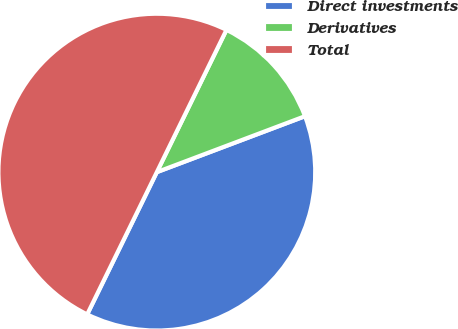Convert chart. <chart><loc_0><loc_0><loc_500><loc_500><pie_chart><fcel>Direct investments<fcel>Derivatives<fcel>Total<nl><fcel>37.99%<fcel>12.01%<fcel>50.0%<nl></chart> 